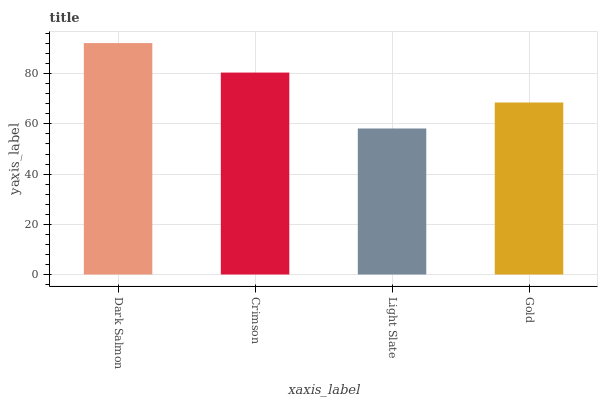Is Crimson the minimum?
Answer yes or no. No. Is Crimson the maximum?
Answer yes or no. No. Is Dark Salmon greater than Crimson?
Answer yes or no. Yes. Is Crimson less than Dark Salmon?
Answer yes or no. Yes. Is Crimson greater than Dark Salmon?
Answer yes or no. No. Is Dark Salmon less than Crimson?
Answer yes or no. No. Is Crimson the high median?
Answer yes or no. Yes. Is Gold the low median?
Answer yes or no. Yes. Is Light Slate the high median?
Answer yes or no. No. Is Crimson the low median?
Answer yes or no. No. 